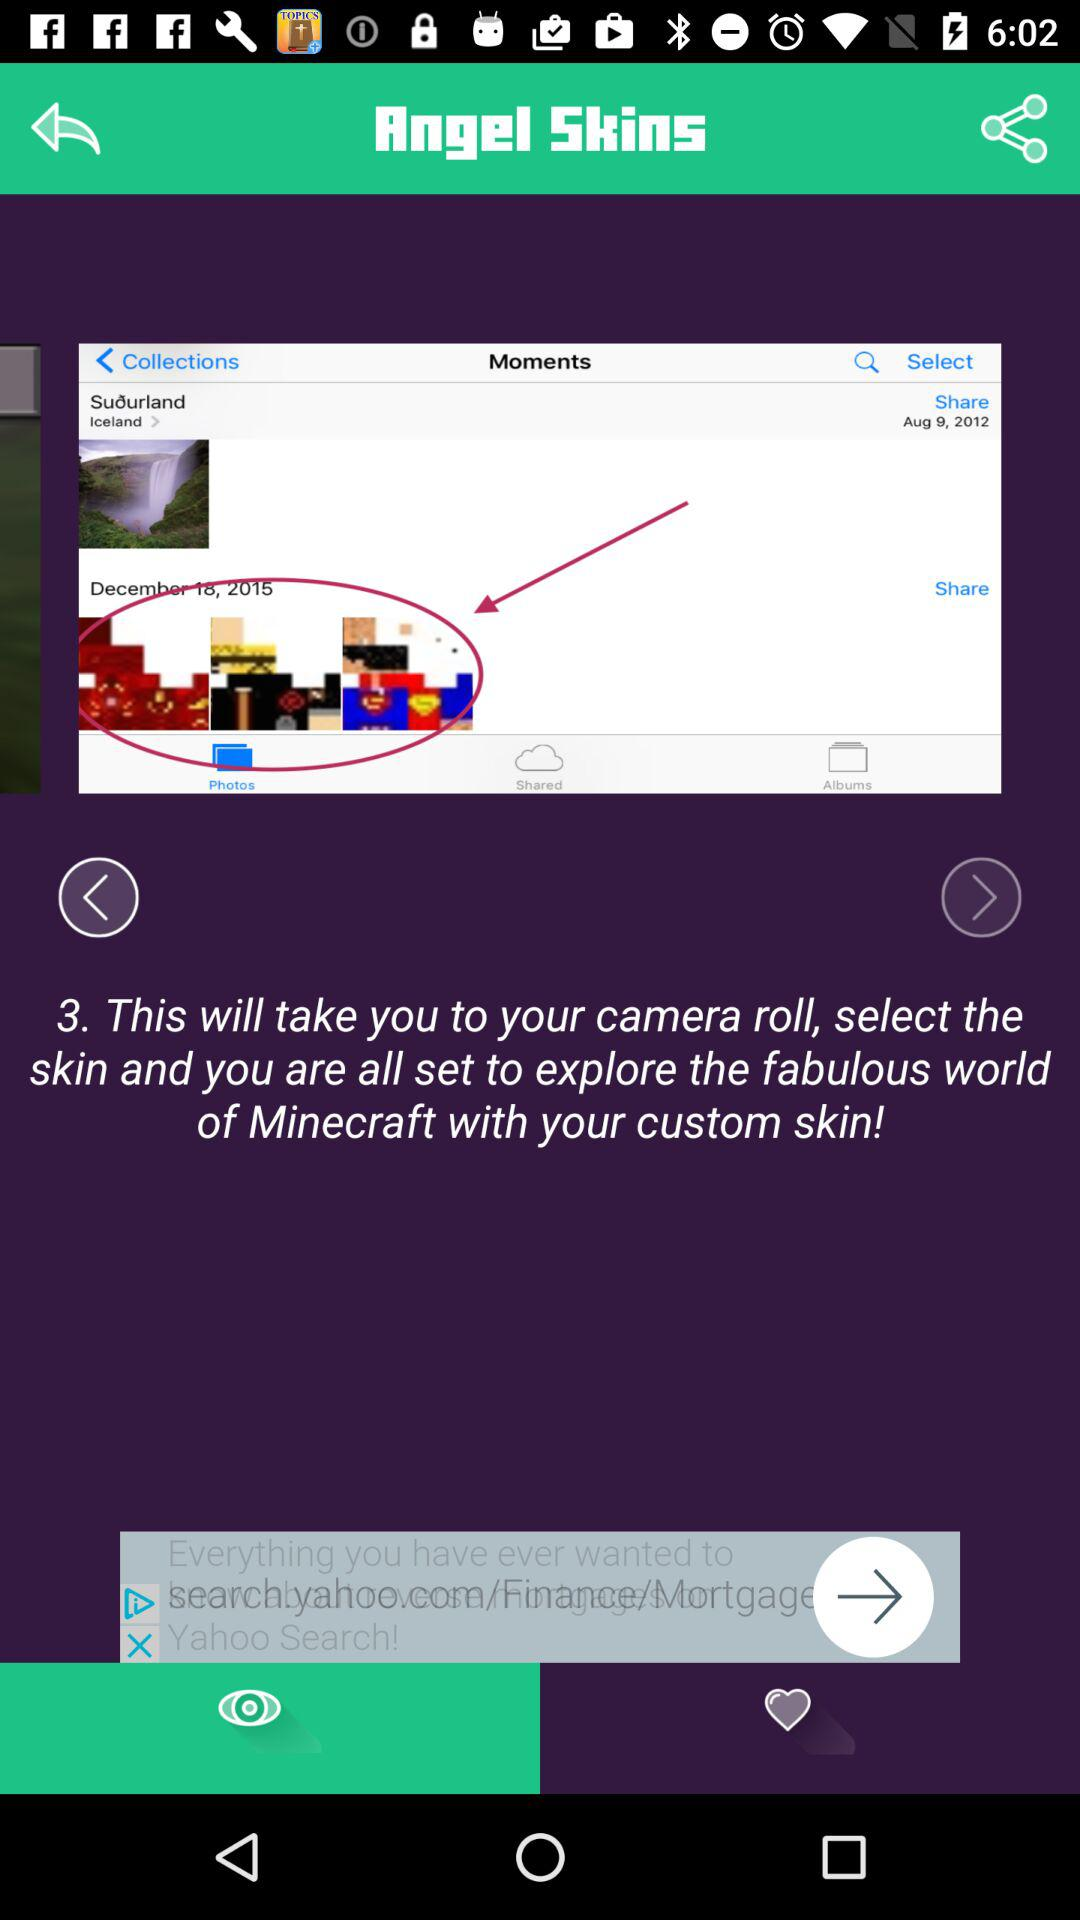What's the total Number of the steps for explore the Fabulous world of Minecraft with the custom skin by Camera?
When the provided information is insufficient, respond with <no answer>. <no answer> 